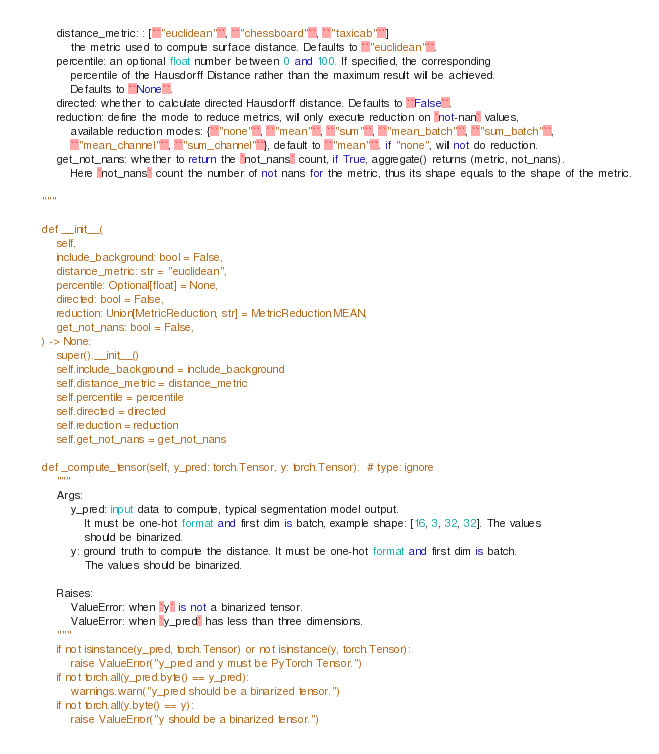<code> <loc_0><loc_0><loc_500><loc_500><_Python_>        distance_metric: : [``"euclidean"``, ``"chessboard"``, ``"taxicab"``]
            the metric used to compute surface distance. Defaults to ``"euclidean"``.
        percentile: an optional float number between 0 and 100. If specified, the corresponding
            percentile of the Hausdorff Distance rather than the maximum result will be achieved.
            Defaults to ``None``.
        directed: whether to calculate directed Hausdorff distance. Defaults to ``False``.
        reduction: define the mode to reduce metrics, will only execute reduction on `not-nan` values,
            available reduction modes: {``"none"``, ``"mean"``, ``"sum"``, ``"mean_batch"``, ``"sum_batch"``,
            ``"mean_channel"``, ``"sum_channel"``}, default to ``"mean"``. if "none", will not do reduction.
        get_not_nans: whether to return the `not_nans` count, if True, aggregate() returns (metric, not_nans).
            Here `not_nans` count the number of not nans for the metric, thus its shape equals to the shape of the metric.

    """

    def __init__(
        self,
        include_background: bool = False,
        distance_metric: str = "euclidean",
        percentile: Optional[float] = None,
        directed: bool = False,
        reduction: Union[MetricReduction, str] = MetricReduction.MEAN,
        get_not_nans: bool = False,
    ) -> None:
        super().__init__()
        self.include_background = include_background
        self.distance_metric = distance_metric
        self.percentile = percentile
        self.directed = directed
        self.reduction = reduction
        self.get_not_nans = get_not_nans

    def _compute_tensor(self, y_pred: torch.Tensor, y: torch.Tensor):  # type: ignore
        """
        Args:
            y_pred: input data to compute, typical segmentation model output.
                It must be one-hot format and first dim is batch, example shape: [16, 3, 32, 32]. The values
                should be binarized.
            y: ground truth to compute the distance. It must be one-hot format and first dim is batch.
                The values should be binarized.

        Raises:
            ValueError: when `y` is not a binarized tensor.
            ValueError: when `y_pred` has less than three dimensions.
        """
        if not isinstance(y_pred, torch.Tensor) or not isinstance(y, torch.Tensor):
            raise ValueError("y_pred and y must be PyTorch Tensor.")
        if not torch.all(y_pred.byte() == y_pred):
            warnings.warn("y_pred should be a binarized tensor.")
        if not torch.all(y.byte() == y):
            raise ValueError("y should be a binarized tensor.")</code> 